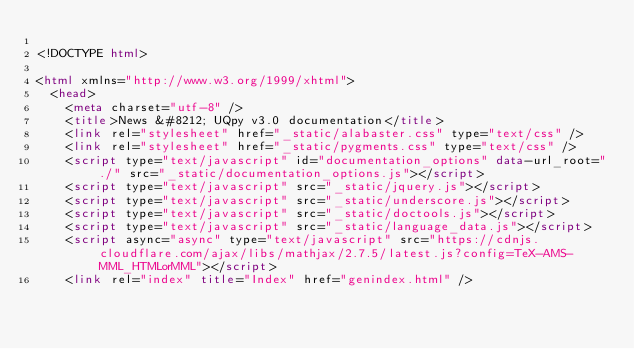Convert code to text. <code><loc_0><loc_0><loc_500><loc_500><_HTML_>
<!DOCTYPE html>

<html xmlns="http://www.w3.org/1999/xhtml">
  <head>
    <meta charset="utf-8" />
    <title>News &#8212; UQpy v3.0 documentation</title>
    <link rel="stylesheet" href="_static/alabaster.css" type="text/css" />
    <link rel="stylesheet" href="_static/pygments.css" type="text/css" />
    <script type="text/javascript" id="documentation_options" data-url_root="./" src="_static/documentation_options.js"></script>
    <script type="text/javascript" src="_static/jquery.js"></script>
    <script type="text/javascript" src="_static/underscore.js"></script>
    <script type="text/javascript" src="_static/doctools.js"></script>
    <script type="text/javascript" src="_static/language_data.js"></script>
    <script async="async" type="text/javascript" src="https://cdnjs.cloudflare.com/ajax/libs/mathjax/2.7.5/latest.js?config=TeX-AMS-MML_HTMLorMML"></script>
    <link rel="index" title="Index" href="genindex.html" /></code> 